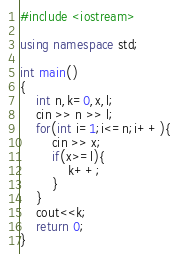Convert code to text. <code><loc_0><loc_0><loc_500><loc_500><_C++_>#include <iostream>

using namespace std;

int main()
{
    int n,k=0,x,l;
    cin >> n >> l;
    for(int i=1;i<=n;i++){
        cin >> x;
        if(x>=l){
            k++;
        }
    }
    cout<<k;
    return 0;
}
</code> 